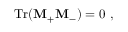<formula> <loc_0><loc_0><loc_500><loc_500>T r ( { M } _ { + } { M } _ { - } ) = 0 \ ,</formula> 